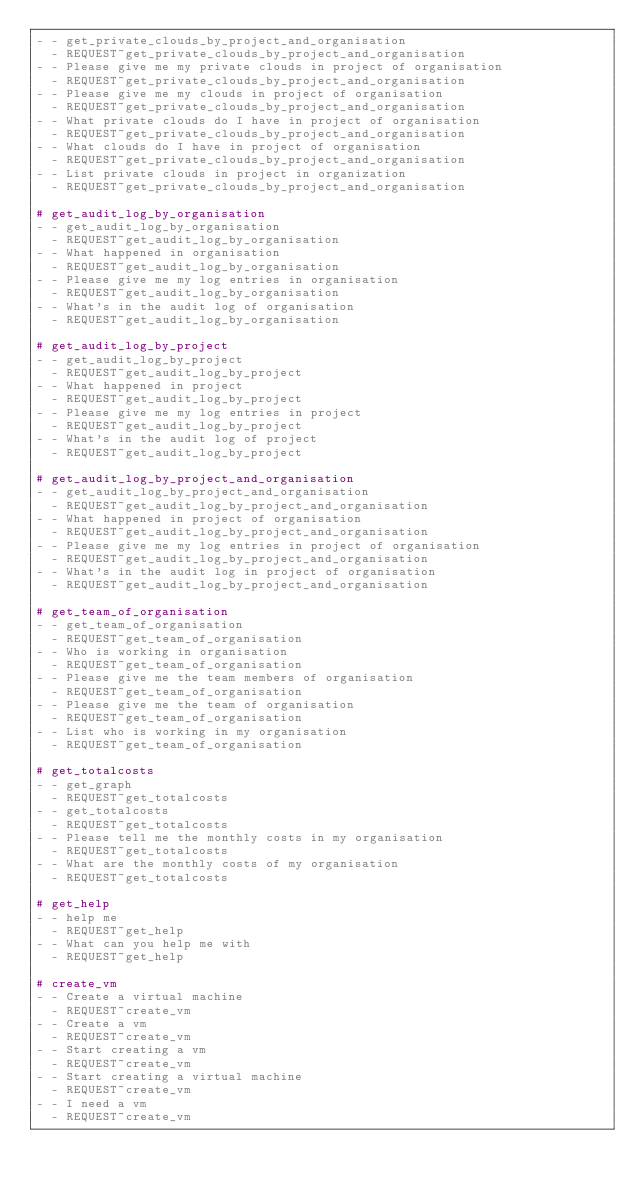<code> <loc_0><loc_0><loc_500><loc_500><_YAML_>- - get_private_clouds_by_project_and_organisation
  - REQUEST~get_private_clouds_by_project_and_organisation
- - Please give me my private clouds in project of organisation
  - REQUEST~get_private_clouds_by_project_and_organisation
- - Please give me my clouds in project of organisation
  - REQUEST~get_private_clouds_by_project_and_organisation
- - What private clouds do I have in project of organisation
  - REQUEST~get_private_clouds_by_project_and_organisation
- - What clouds do I have in project of organisation
  - REQUEST~get_private_clouds_by_project_and_organisation
- - List private clouds in project in organization
  - REQUEST~get_private_clouds_by_project_and_organisation

# get_audit_log_by_organisation
- - get_audit_log_by_organisation
  - REQUEST~get_audit_log_by_organisation
- - What happened in organisation
  - REQUEST~get_audit_log_by_organisation
- - Please give me my log entries in organisation
  - REQUEST~get_audit_log_by_organisation
- - What's in the audit log of organisation
  - REQUEST~get_audit_log_by_organisation

# get_audit_log_by_project
- - get_audit_log_by_project
  - REQUEST~get_audit_log_by_project
- - What happened in project
  - REQUEST~get_audit_log_by_project
- - Please give me my log entries in project
  - REQUEST~get_audit_log_by_project
- - What's in the audit log of project
  - REQUEST~get_audit_log_by_project

# get_audit_log_by_project_and_organisation
- - get_audit_log_by_project_and_organisation
  - REQUEST~get_audit_log_by_project_and_organisation
- - What happened in project of organisation
  - REQUEST~get_audit_log_by_project_and_organisation
- - Please give me my log entries in project of organisation
  - REQUEST~get_audit_log_by_project_and_organisation
- - What's in the audit log in project of organisation
  - REQUEST~get_audit_log_by_project_and_organisation

# get_team_of_organisation
- - get_team_of_organisation
  - REQUEST~get_team_of_organisation
- - Who is working in organisation
  - REQUEST~get_team_of_organisation
- - Please give me the team members of organisation
  - REQUEST~get_team_of_organisation
- - Please give me the team of organisation
  - REQUEST~get_team_of_organisation
- - List who is working in my organisation
  - REQUEST~get_team_of_organisation

# get_totalcosts
- - get_graph
  - REQUEST~get_totalcosts
- - get_totalcosts
  - REQUEST~get_totalcosts
- - Please tell me the monthly costs in my organisation
  - REQUEST~get_totalcosts
- - What are the monthly costs of my organisation
  - REQUEST~get_totalcosts

# get_help
- - help me
  - REQUEST~get_help
- - What can you help me with
  - REQUEST~get_help

# create_vm
- - Create a virtual machine
  - REQUEST~create_vm
- - Create a vm
  - REQUEST~create_vm
- - Start creating a vm
  - REQUEST~create_vm
- - Start creating a virtual machine
  - REQUEST~create_vm
- - I need a vm
  - REQUEST~create_vm</code> 